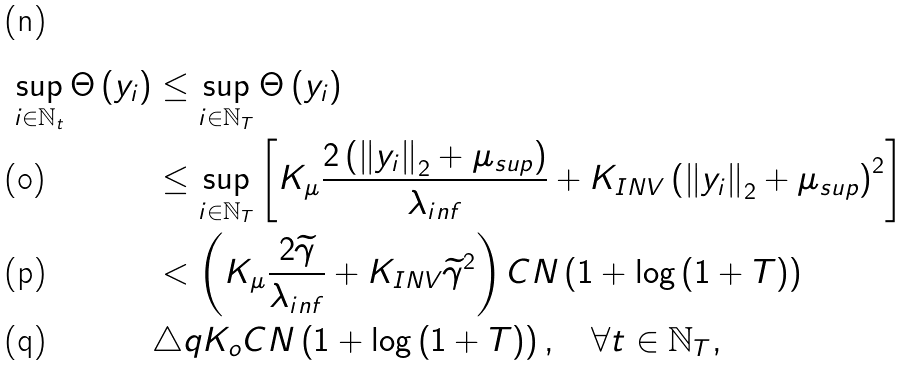Convert formula to latex. <formula><loc_0><loc_0><loc_500><loc_500>\sup _ { i \in \mathbb { N } _ { t } } \Theta \left ( { y } _ { i } \right ) & \leq \sup _ { i \in \mathbb { N } _ { T } } \Theta \left ( { y } _ { i } \right ) \\ & \leq \sup _ { i \in \mathbb { N } _ { T } } \left [ K _ { \mu } \frac { 2 \left ( \left \| { y } _ { i } \right \| _ { 2 } + \mu _ { s u p } \right ) } { \lambda _ { i n f } } + K _ { I N V } \left ( \left \| { y } _ { i } \right \| _ { 2 } + \mu _ { s u p } \right ) ^ { 2 } \right ] \\ & < \left ( K _ { \mu } \frac { 2 \widetilde { \gamma } } { \lambda _ { i n f } } + K _ { I N V } \widetilde { \gamma } ^ { 2 } \right ) C N \left ( 1 + \log \left ( 1 + T \right ) \right ) \\ & \triangle q K _ { o } C N \left ( 1 + \log \left ( 1 + T \right ) \right ) , \quad \forall t \in \mathbb { N } _ { T } ,</formula> 